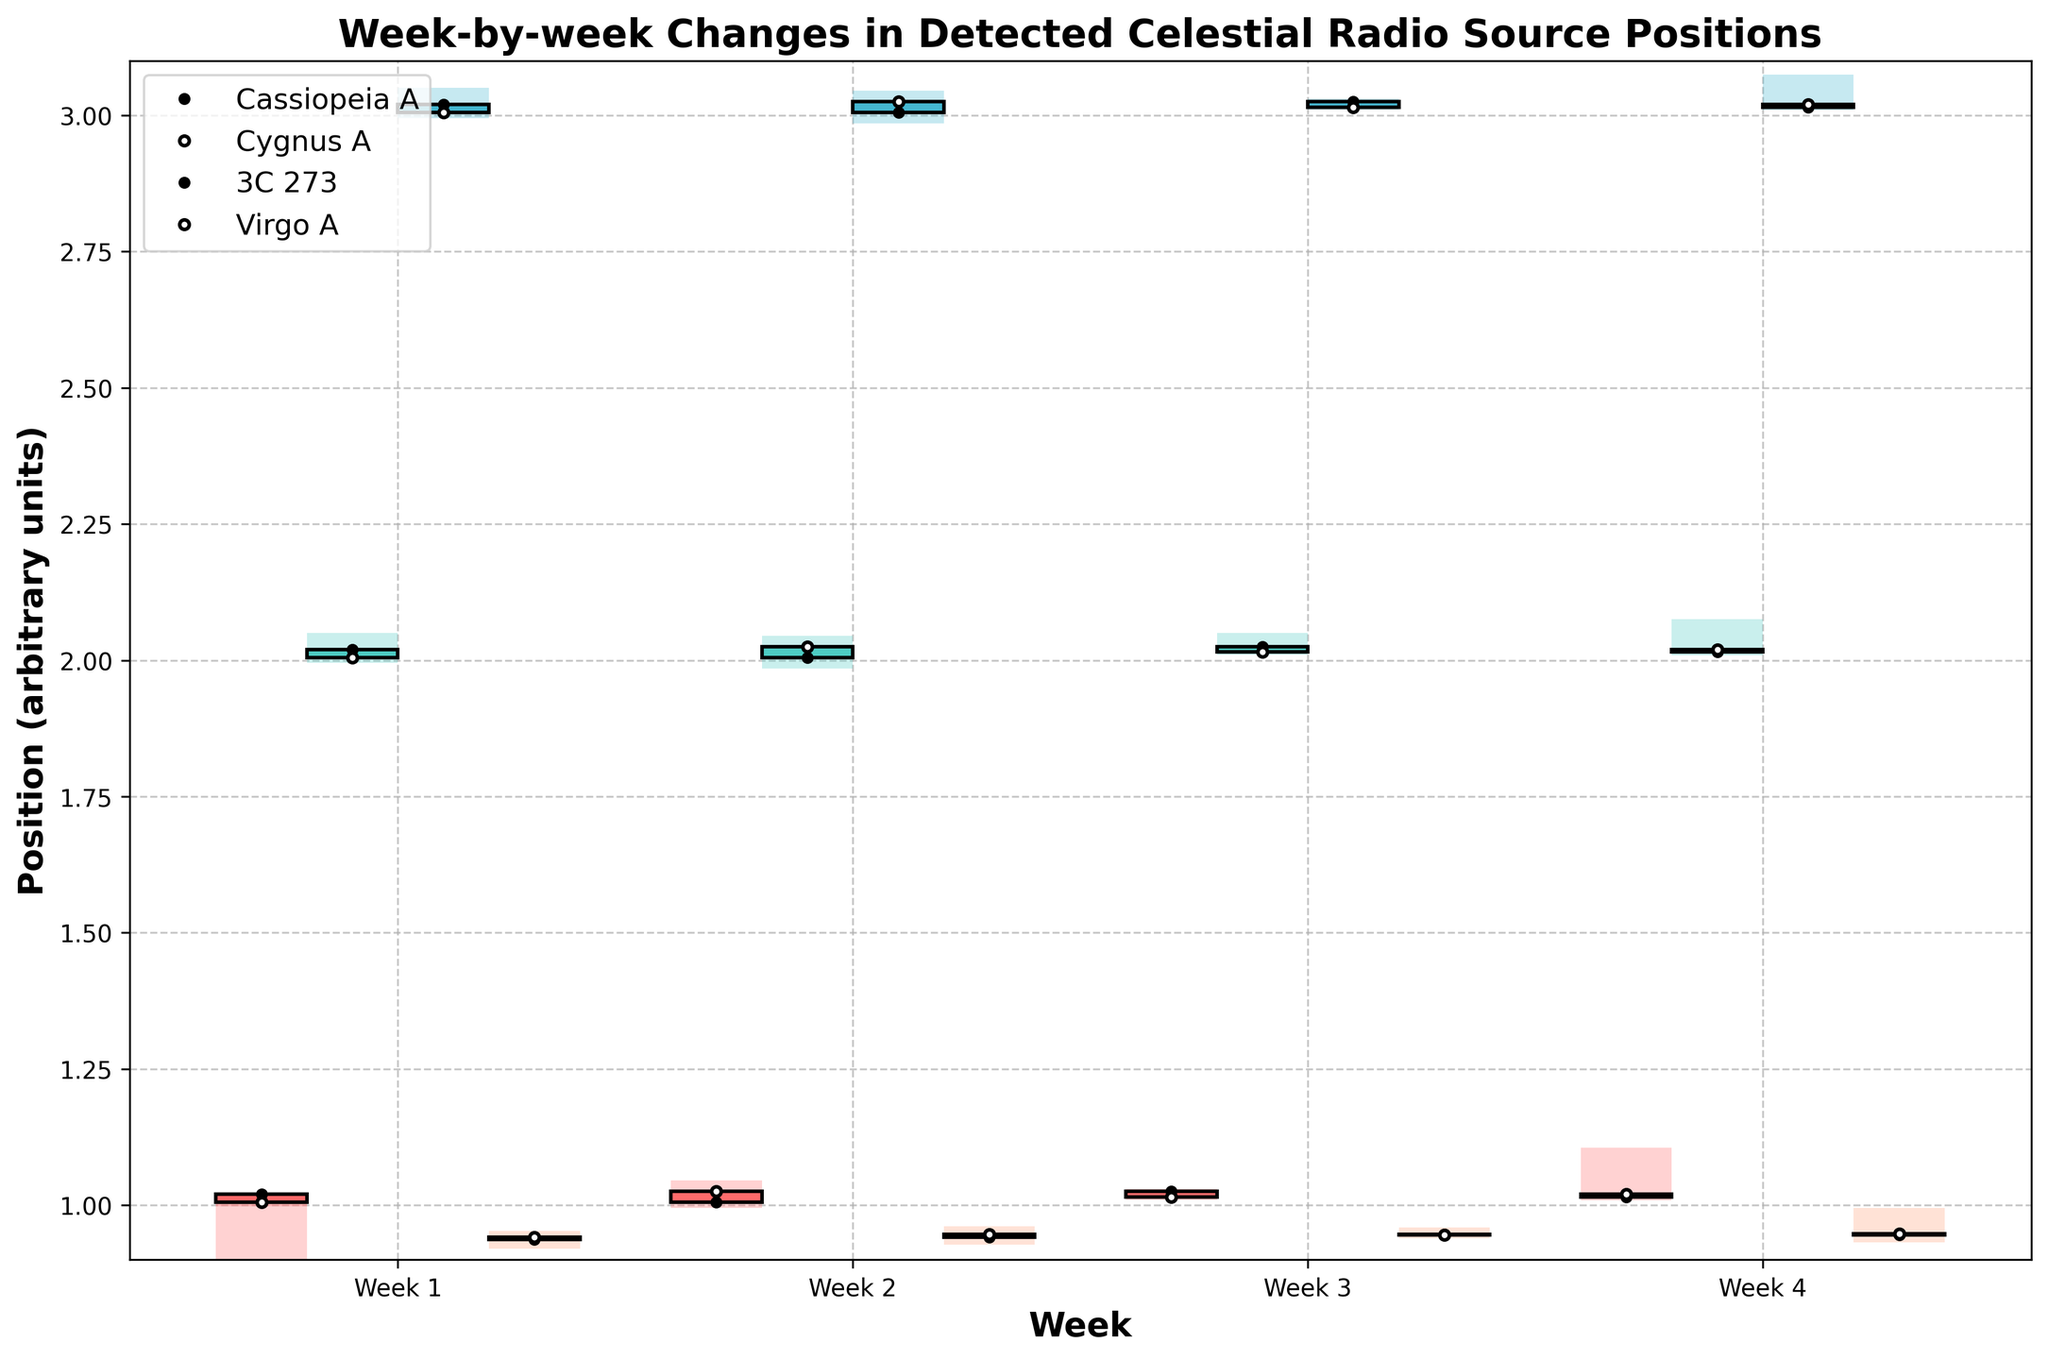What is the title of the plot? The title is typically located at the top of the figure. In this case, it is explicitly stated in the code, so we can read it directly.
Answer: Week-by-week Changes in Detected Celestial Radio Source Positions Which radio source shows the highest position change in Week 4? By comparing the height of the bars for Week 4 across all radio sources, we see that Cassiopeia A has the highest peak ('High' value of 1.105) in Week 4.
Answer: Cassiopeia A How does the position of Cygnus A change from Week 1 to Week 4? We need to find the 'Open' and 'Close' positions for Cygnus A from Week 1 to Week 4 and observe the trend. Weeks 1 to 4 'Open' values are 2.020, 2.005, 2.025, 2.015, and 'Close' values are 2.005, 2.025, 2.015, 2.020. There's a slight fluctuation but no significant change overall.
Answer: Slight fluctuation Which week shows the most substantial increase in the position for 3C 273? By examining the week-by-week 'Open' to 'Close' changes for 3C 273, the most substantial increase is observed between Week 1 ('Open' 3.020 and 'Close' 3.005) and Week 2 ('Open' 3.005 and 'Close' 3.025), an overall increase of 0.020.
Answer: Week 2 Compare the average 'Close' position for all radio sources in Week 2. We need to calculate the average of the 'Close' values for Week 2. Compute (1.025 + 2.025 + 3.025 + 0.947) / 4 = 7.022 / 4.
Answer: 1.7555 Which radio source has the smallest variation in Week 3, and what is the variation? The variation is the difference between 'High' and 'Low'. For Week 3: Cassiopeia A: 1.030 - 1.010, Cygnus A: 2.050 - 2.010, 3C 273: 3.030 - 3.010, Virgo A: 0.959 - 0.939. The smallest variation is for 3C 273 (3.030 - 3.010 = 0.020).
Answer: 3C 273, 0.020 Which radio source has the highest 'Open' position in Week 1? Compare the 'Open' values for Week 1 across all radio sources: Cassiopeia A (1.020), Cygnus A (2.020), 3C 273 (3.020), Virgo A (0.937). 3C 273 has the highest 'Open' value.
Answer: 3C 273 What is the average 'High' value for Cygnus A over the four weeks? Sum up the 'High' values for Cygnus A and divide by 4. Compute (2.050 + 2.045 + 2.050 + 2.075) / 4 = 8.220 / 4.
Answer: 2.055 